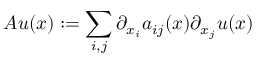Convert formula to latex. <formula><loc_0><loc_0><loc_500><loc_500>A u ( x ) \colon = \sum _ { i , j } \partial _ { x _ { i } } a _ { i j } ( x ) \partial _ { x _ { j } } u ( x )</formula> 